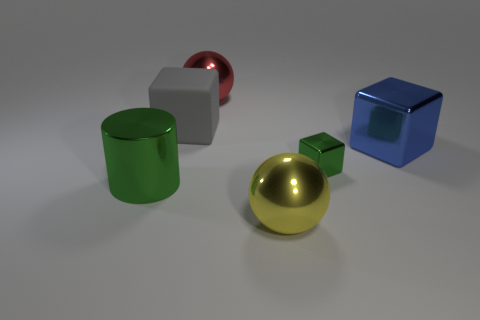Subtract all brown cubes. Subtract all purple cylinders. How many cubes are left? 3 Add 4 green blocks. How many objects exist? 10 Subtract all spheres. How many objects are left? 4 Subtract all spheres. Subtract all green shiny objects. How many objects are left? 2 Add 1 green shiny cylinders. How many green shiny cylinders are left? 2 Add 1 yellow things. How many yellow things exist? 2 Subtract 1 blue cubes. How many objects are left? 5 